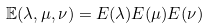<formula> <loc_0><loc_0><loc_500><loc_500>\mathbb { E } ( \lambda , \mu , \nu ) = E ( \lambda ) E ( \mu ) E ( \nu )</formula> 